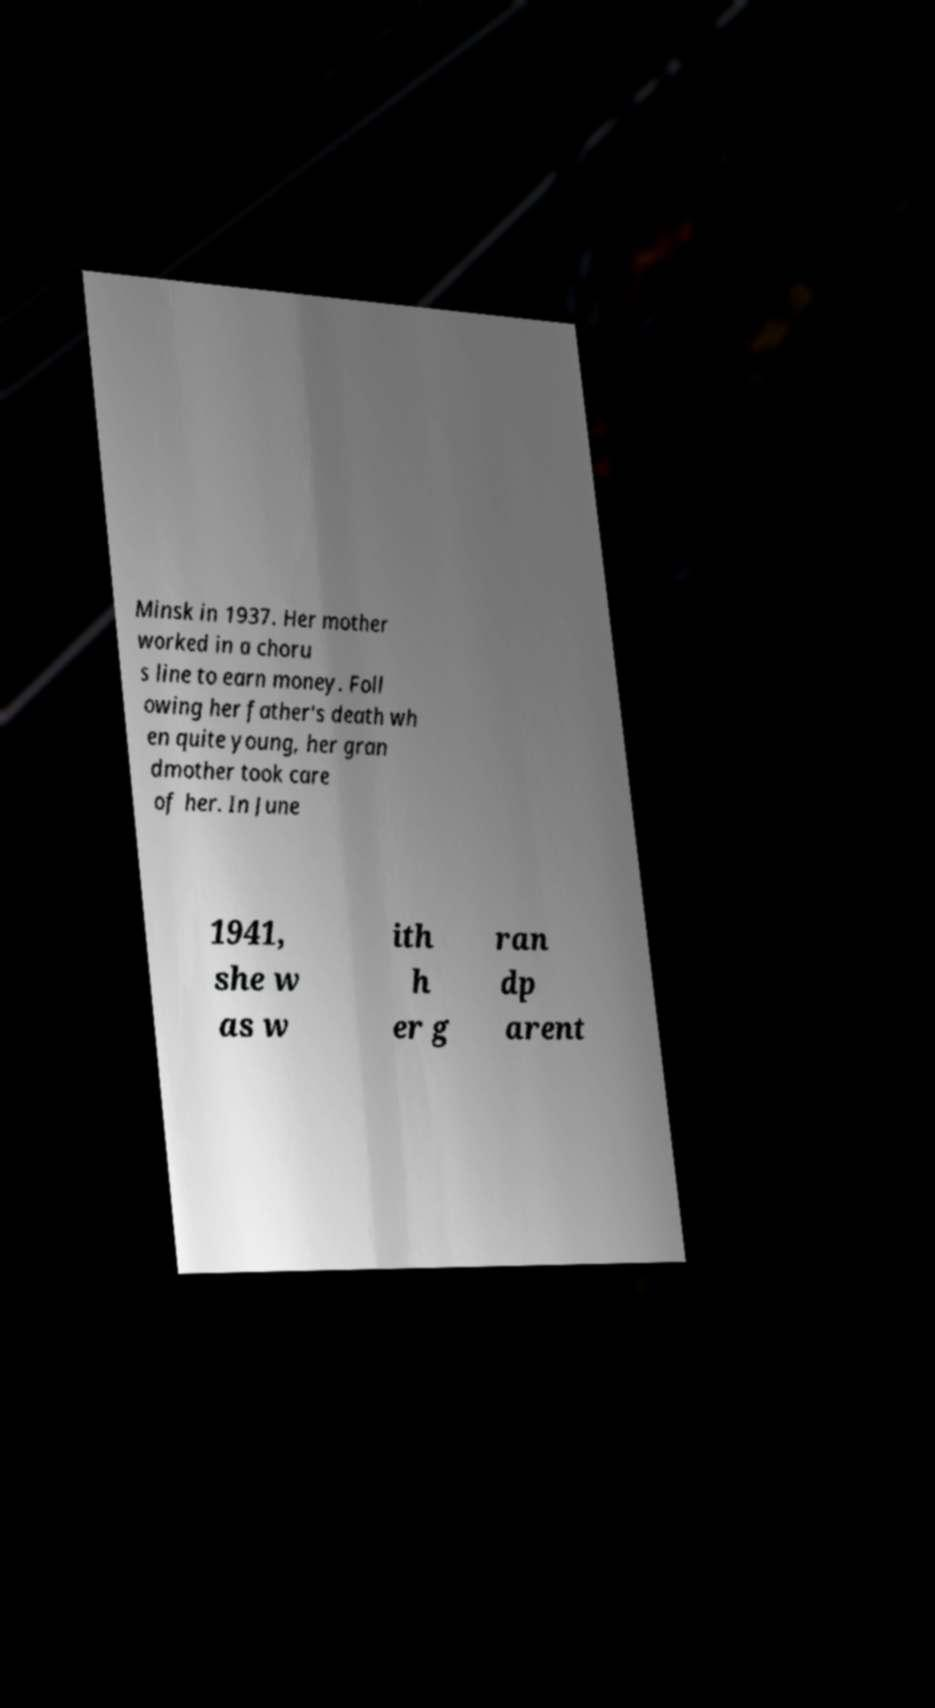Could you assist in decoding the text presented in this image and type it out clearly? Minsk in 1937. Her mother worked in a choru s line to earn money. Foll owing her father's death wh en quite young, her gran dmother took care of her. In June 1941, she w as w ith h er g ran dp arent 